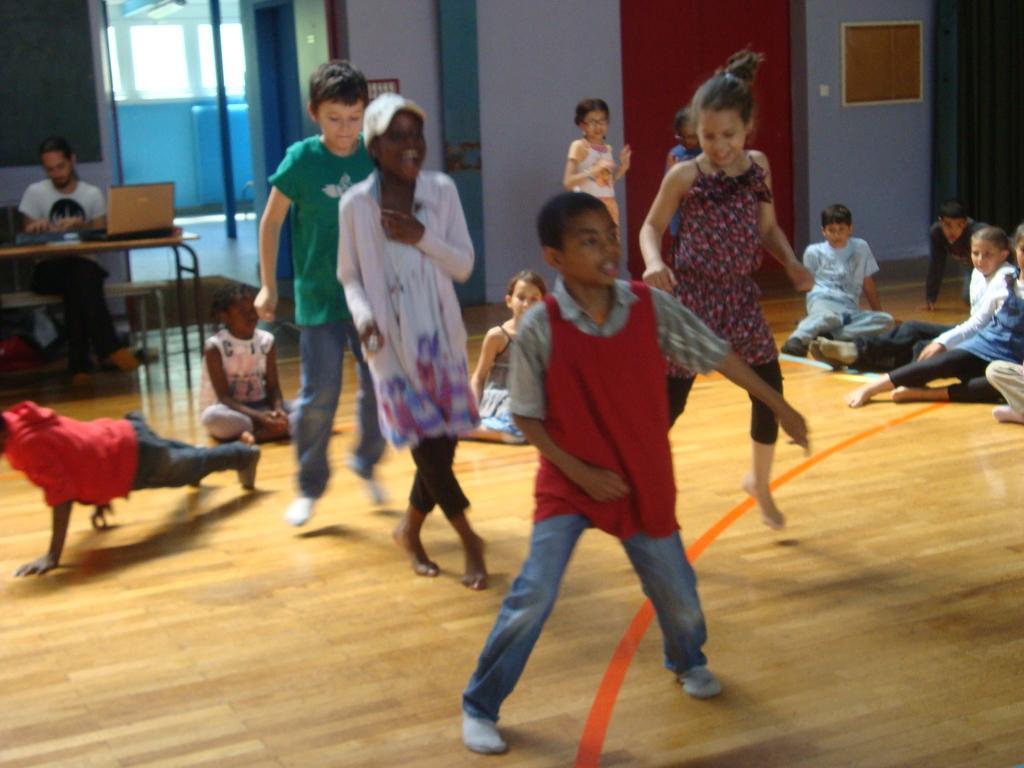In one or two sentences, can you explain what this image depicts? In this image, we can see few childrens are dancing on the floor. Few are sitting and standing. On the left side, a person is sitting. There is a table, laptop. Few objects are placed on the table. Background there is a wallboard, pole, pillars. 